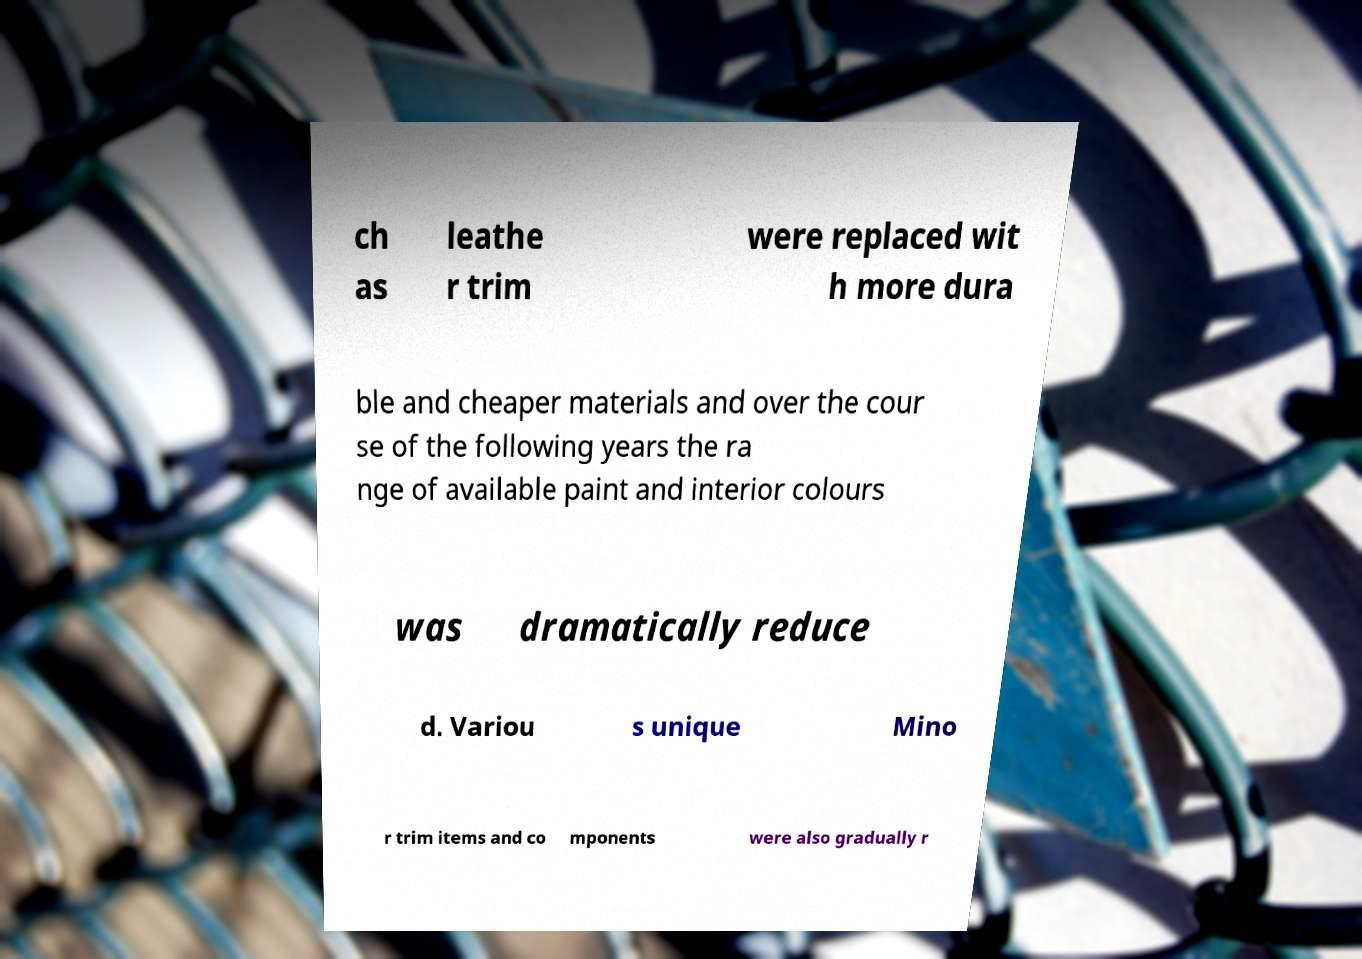For documentation purposes, I need the text within this image transcribed. Could you provide that? ch as leathe r trim were replaced wit h more dura ble and cheaper materials and over the cour se of the following years the ra nge of available paint and interior colours was dramatically reduce d. Variou s unique Mino r trim items and co mponents were also gradually r 